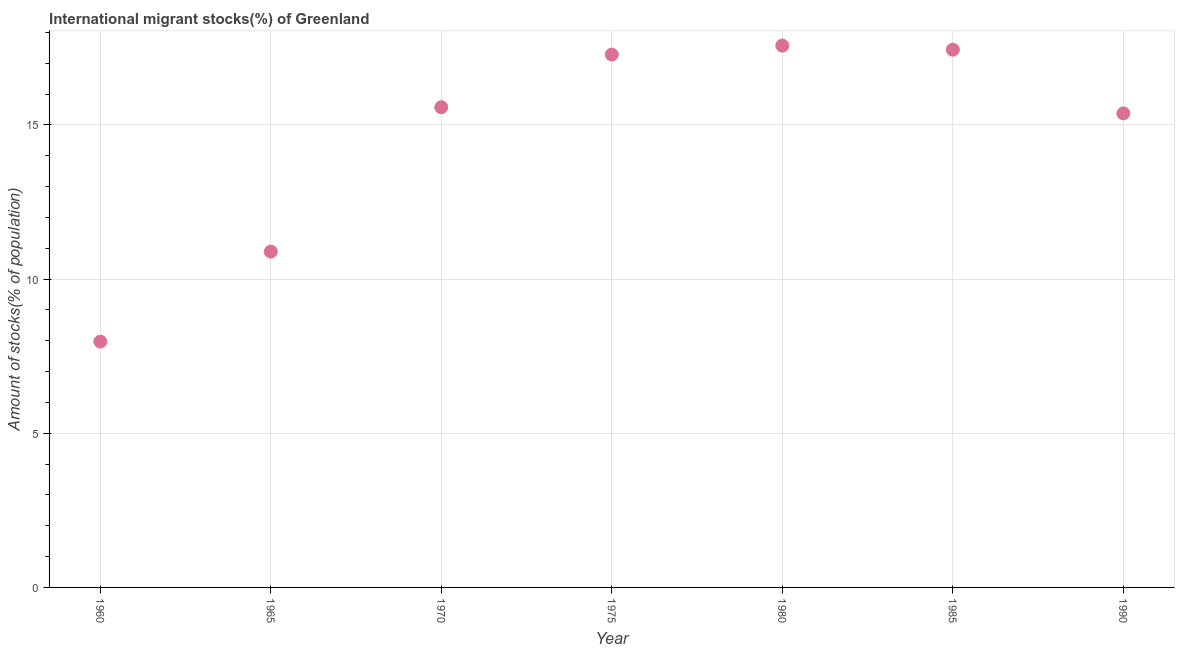What is the number of international migrant stocks in 1990?
Offer a terse response. 15.37. Across all years, what is the maximum number of international migrant stocks?
Your response must be concise. 17.57. Across all years, what is the minimum number of international migrant stocks?
Your answer should be compact. 7.97. What is the sum of the number of international migrant stocks?
Your answer should be very brief. 102.09. What is the difference between the number of international migrant stocks in 1960 and 1980?
Your response must be concise. -9.6. What is the average number of international migrant stocks per year?
Give a very brief answer. 14.58. What is the median number of international migrant stocks?
Make the answer very short. 15.57. Do a majority of the years between 1975 and 1960 (inclusive) have number of international migrant stocks greater than 17 %?
Keep it short and to the point. Yes. What is the ratio of the number of international migrant stocks in 1975 to that in 1985?
Give a very brief answer. 0.99. What is the difference between the highest and the second highest number of international migrant stocks?
Provide a succinct answer. 0.13. Is the sum of the number of international migrant stocks in 1980 and 1990 greater than the maximum number of international migrant stocks across all years?
Give a very brief answer. Yes. What is the difference between the highest and the lowest number of international migrant stocks?
Your answer should be compact. 9.6. In how many years, is the number of international migrant stocks greater than the average number of international migrant stocks taken over all years?
Make the answer very short. 5. Does the number of international migrant stocks monotonically increase over the years?
Provide a short and direct response. No. How many dotlines are there?
Ensure brevity in your answer.  1. Are the values on the major ticks of Y-axis written in scientific E-notation?
Your response must be concise. No. Does the graph contain any zero values?
Your answer should be very brief. No. Does the graph contain grids?
Give a very brief answer. Yes. What is the title of the graph?
Your answer should be very brief. International migrant stocks(%) of Greenland. What is the label or title of the X-axis?
Your response must be concise. Year. What is the label or title of the Y-axis?
Ensure brevity in your answer.  Amount of stocks(% of population). What is the Amount of stocks(% of population) in 1960?
Provide a succinct answer. 7.97. What is the Amount of stocks(% of population) in 1965?
Your answer should be very brief. 10.89. What is the Amount of stocks(% of population) in 1970?
Give a very brief answer. 15.57. What is the Amount of stocks(% of population) in 1975?
Your answer should be very brief. 17.28. What is the Amount of stocks(% of population) in 1980?
Ensure brevity in your answer.  17.57. What is the Amount of stocks(% of population) in 1985?
Offer a very short reply. 17.44. What is the Amount of stocks(% of population) in 1990?
Keep it short and to the point. 15.37. What is the difference between the Amount of stocks(% of population) in 1960 and 1965?
Ensure brevity in your answer.  -2.92. What is the difference between the Amount of stocks(% of population) in 1960 and 1970?
Your response must be concise. -7.6. What is the difference between the Amount of stocks(% of population) in 1960 and 1975?
Your answer should be compact. -9.31. What is the difference between the Amount of stocks(% of population) in 1960 and 1980?
Your answer should be very brief. -9.6. What is the difference between the Amount of stocks(% of population) in 1960 and 1985?
Provide a short and direct response. -9.47. What is the difference between the Amount of stocks(% of population) in 1960 and 1990?
Provide a succinct answer. -7.4. What is the difference between the Amount of stocks(% of population) in 1965 and 1970?
Keep it short and to the point. -4.68. What is the difference between the Amount of stocks(% of population) in 1965 and 1975?
Your response must be concise. -6.39. What is the difference between the Amount of stocks(% of population) in 1965 and 1980?
Make the answer very short. -6.68. What is the difference between the Amount of stocks(% of population) in 1965 and 1985?
Provide a short and direct response. -6.55. What is the difference between the Amount of stocks(% of population) in 1965 and 1990?
Your answer should be compact. -4.48. What is the difference between the Amount of stocks(% of population) in 1970 and 1975?
Your response must be concise. -1.71. What is the difference between the Amount of stocks(% of population) in 1970 and 1980?
Your answer should be compact. -2. What is the difference between the Amount of stocks(% of population) in 1970 and 1985?
Ensure brevity in your answer.  -1.87. What is the difference between the Amount of stocks(% of population) in 1970 and 1990?
Offer a terse response. 0.2. What is the difference between the Amount of stocks(% of population) in 1975 and 1980?
Keep it short and to the point. -0.29. What is the difference between the Amount of stocks(% of population) in 1975 and 1985?
Offer a very short reply. -0.16. What is the difference between the Amount of stocks(% of population) in 1975 and 1990?
Make the answer very short. 1.91. What is the difference between the Amount of stocks(% of population) in 1980 and 1985?
Ensure brevity in your answer.  0.13. What is the difference between the Amount of stocks(% of population) in 1980 and 1990?
Your answer should be very brief. 2.2. What is the difference between the Amount of stocks(% of population) in 1985 and 1990?
Offer a terse response. 2.07. What is the ratio of the Amount of stocks(% of population) in 1960 to that in 1965?
Your answer should be compact. 0.73. What is the ratio of the Amount of stocks(% of population) in 1960 to that in 1970?
Offer a very short reply. 0.51. What is the ratio of the Amount of stocks(% of population) in 1960 to that in 1975?
Keep it short and to the point. 0.46. What is the ratio of the Amount of stocks(% of population) in 1960 to that in 1980?
Offer a very short reply. 0.45. What is the ratio of the Amount of stocks(% of population) in 1960 to that in 1985?
Offer a very short reply. 0.46. What is the ratio of the Amount of stocks(% of population) in 1960 to that in 1990?
Offer a terse response. 0.52. What is the ratio of the Amount of stocks(% of population) in 1965 to that in 1970?
Give a very brief answer. 0.7. What is the ratio of the Amount of stocks(% of population) in 1965 to that in 1975?
Your response must be concise. 0.63. What is the ratio of the Amount of stocks(% of population) in 1965 to that in 1980?
Your answer should be very brief. 0.62. What is the ratio of the Amount of stocks(% of population) in 1965 to that in 1985?
Give a very brief answer. 0.62. What is the ratio of the Amount of stocks(% of population) in 1965 to that in 1990?
Provide a succinct answer. 0.71. What is the ratio of the Amount of stocks(% of population) in 1970 to that in 1975?
Offer a very short reply. 0.9. What is the ratio of the Amount of stocks(% of population) in 1970 to that in 1980?
Your answer should be compact. 0.89. What is the ratio of the Amount of stocks(% of population) in 1970 to that in 1985?
Your response must be concise. 0.89. What is the ratio of the Amount of stocks(% of population) in 1970 to that in 1990?
Make the answer very short. 1.01. What is the ratio of the Amount of stocks(% of population) in 1975 to that in 1980?
Provide a short and direct response. 0.98. What is the ratio of the Amount of stocks(% of population) in 1975 to that in 1990?
Ensure brevity in your answer.  1.12. What is the ratio of the Amount of stocks(% of population) in 1980 to that in 1990?
Your answer should be very brief. 1.14. What is the ratio of the Amount of stocks(% of population) in 1985 to that in 1990?
Offer a terse response. 1.13. 